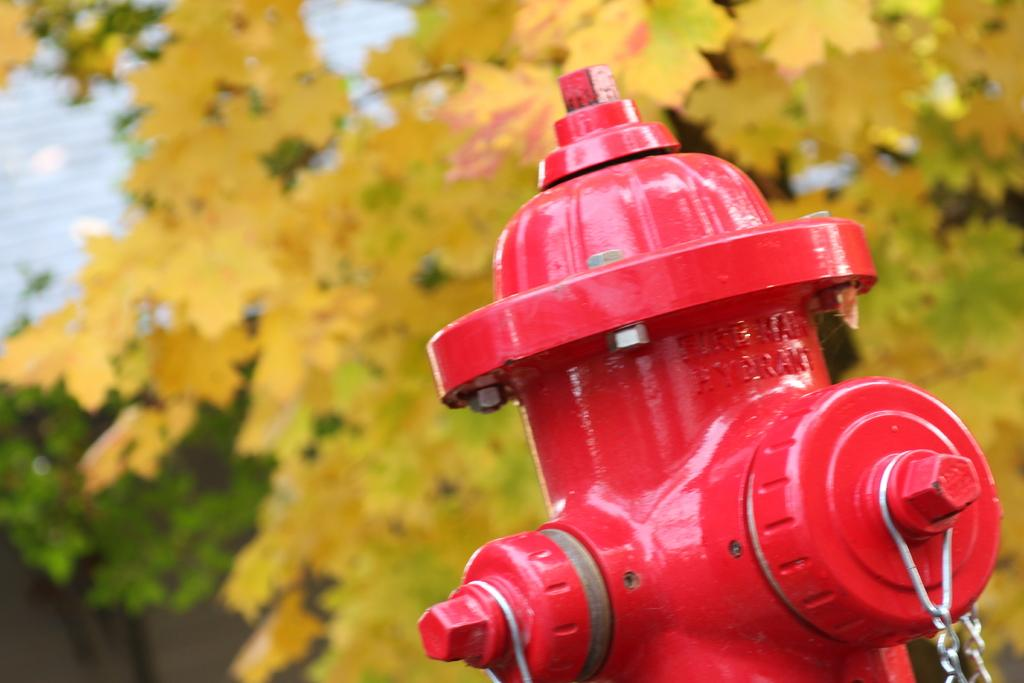What object can be seen in the image that is typically used for firefighting? There is a fire hydrant in the image. What can be seen in the background of the image? There are leaves in the background of the image. What colors are the leaves in the image? The leaves are in green and yellow colors. What type of bone can be seen in the image? There is no bone present in the image; it features a fire hydrant and leaves. 